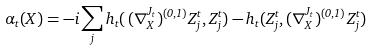<formula> <loc_0><loc_0><loc_500><loc_500>\alpha _ { t } ( X ) = - i \sum _ { j } h _ { t } ( \, ( \nabla _ { X } ^ { J _ { t } } ) ^ { ( 0 , 1 ) } Z _ { j } ^ { t } , Z _ { j } ^ { t } ) - h _ { t } ( Z _ { j } ^ { t } , ( \nabla _ { X } ^ { J _ { t } } ) ^ { ( 0 , 1 ) } Z _ { j } ^ { t } )</formula> 